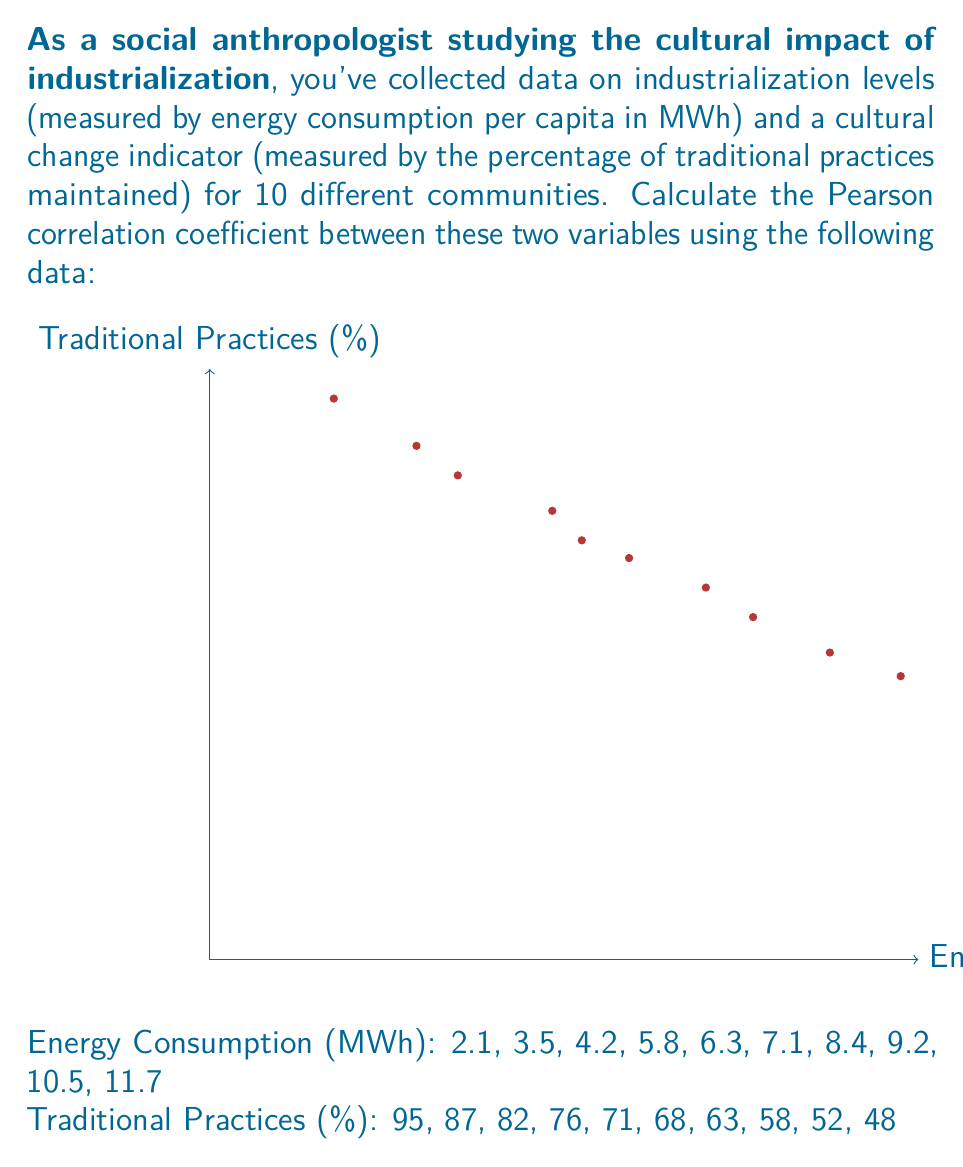Help me with this question. To calculate the Pearson correlation coefficient (r), we'll follow these steps:

1. Calculate the means of x (Energy Consumption) and y (Traditional Practices):
   $$\bar{x} = \frac{\sum x_i}{n} = \frac{68.8}{10} = 6.88$$
   $$\bar{y} = \frac{\sum y_i}{n} = \frac{700}{10} = 70$$

2. Calculate the deviations from the mean for both x and y:
   $x_i - \bar{x}$ and $y_i - \bar{y}$

3. Calculate the products of these deviations:
   $(x_i - \bar{x})(y_i - \bar{y})$

4. Sum up these products:
   $$\sum (x_i - \bar{x})(y_i - \bar{y}) = -435.04$$

5. Calculate the sum of squared deviations for x and y:
   $$\sum (x_i - \bar{x})^2 = 105.856$$
   $$\sum (y_i - \bar{y})^2 = 2330$$

6. Apply the formula for the Pearson correlation coefficient:
   $$r = \frac{\sum (x_i - \bar{x})(y_i - \bar{y})}{\sqrt{\sum (x_i - \bar{x})^2 \sum (y_i - \bar{y})^2}}$$

7. Substitute the values:
   $$r = \frac{-435.04}{\sqrt{105.856 \times 2330}} = \frac{-435.04}{496.91}$$

8. Calculate the final result:
   $$r \approx -0.8755$$

The correlation coefficient is approximately -0.8755, indicating a strong negative correlation between industrialization levels and the maintenance of traditional practices.
Answer: $r \approx -0.8755$ 